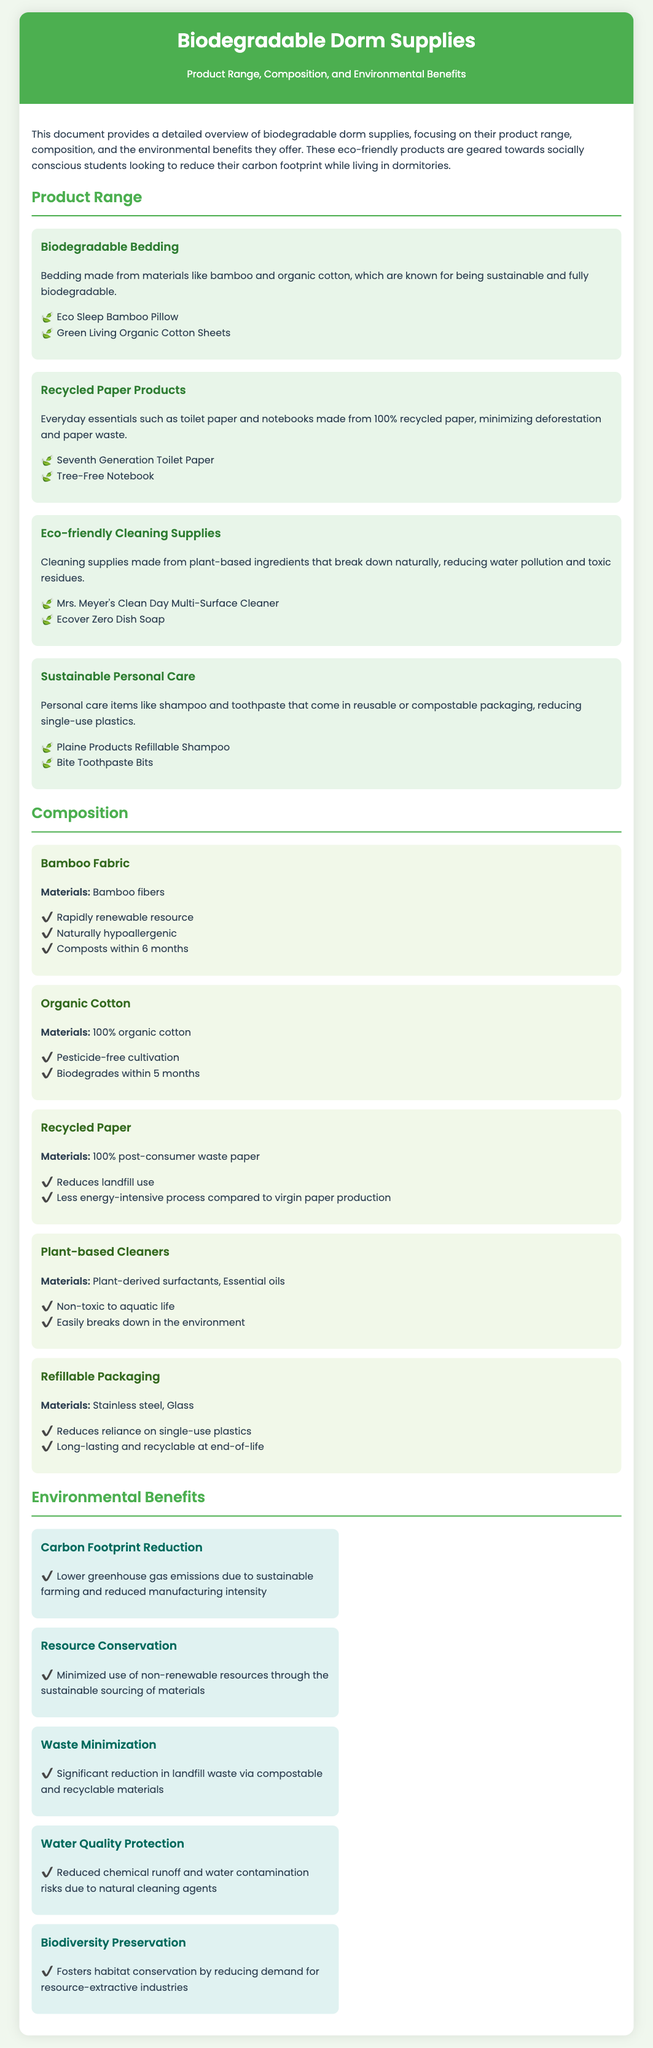What products are included in the biodegradable bedding category? The document lists two products under biodegradable bedding: Eco Sleep Bamboo Pillow and Green Living Organic Cotton Sheets.
Answer: Eco Sleep Bamboo Pillow, Green Living Organic Cotton Sheets What are the materials used in organic cotton? The document specifies that organic cotton is made from 100% organic cotton.
Answer: 100% organic cotton How long does bamboo fabric take to compost? The document states that bamboo fabric composts within 6 months.
Answer: 6 months What is one environmental benefit of using plant-based cleaners? The document mentions reducing chemical runoff and water contamination as a benefit of plant-based cleaners, making them non-toxic to aquatic life.
Answer: Non-toxic to aquatic life How do refillable packaging materials contribute to sustainability? Refillable packaging reduces reliance on single-use plastics and is long-lasting and recyclable at end-of-life.
Answer: Reduces reliance on single-use plastics What is the main purpose of the document? The document aims to provide a detailed overview of biodegradable dorm supplies, focusing on their product range, composition, and environmental benefits.
Answer: To provide a detailed overview of biodegradable dorm supplies What type of personal care items are included in the product range? The document includes items like shampoo and toothpaste that come in reusable or compostable packaging.
Answer: Reusable or compostable packaging How does the use of recycled paper benefit the environment? The document states that using recycled paper reduces landfill use and is less energy-intensive compared to virgin paper production.
Answer: Reduces landfill use What is one way that biodegradable dorm supplies benefit biodiversity? The document indicates that these supplies foster habitat conservation by reducing demand for resource-extractive industries.
Answer: Foster habitat conservation 